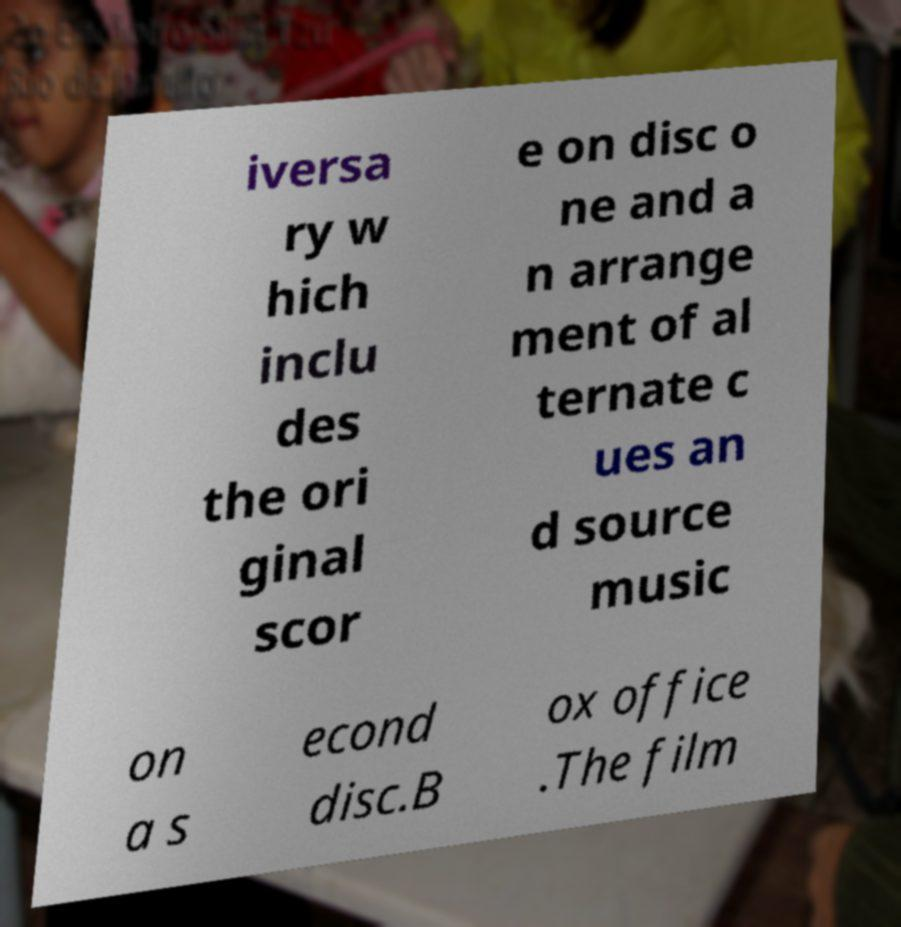For documentation purposes, I need the text within this image transcribed. Could you provide that? iversa ry w hich inclu des the ori ginal scor e on disc o ne and a n arrange ment of al ternate c ues an d source music on a s econd disc.B ox office .The film 